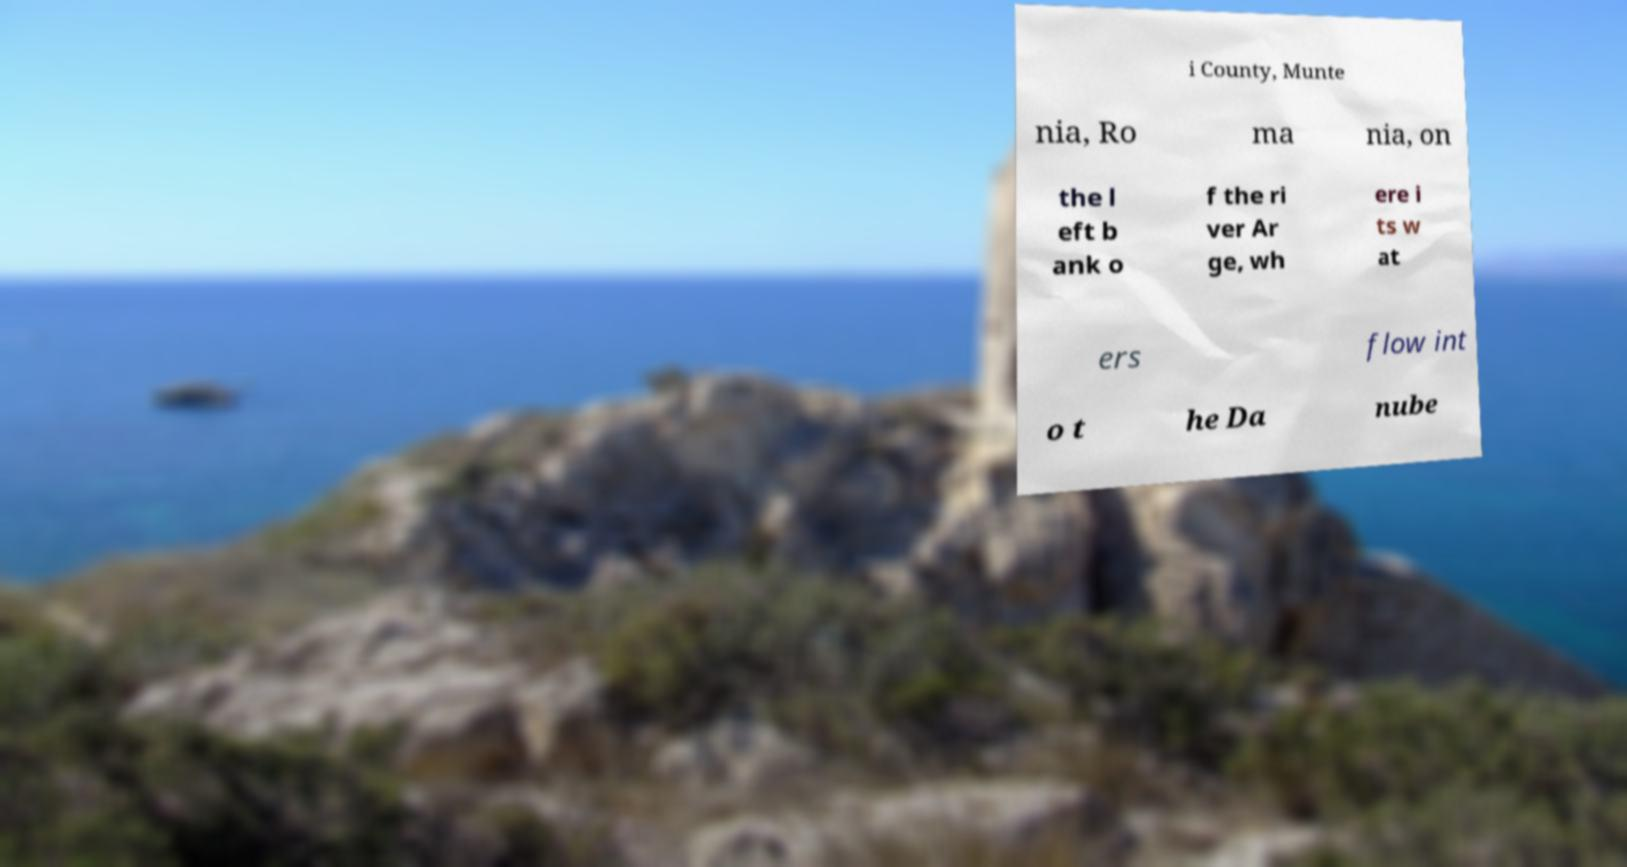Could you assist in decoding the text presented in this image and type it out clearly? i County, Munte nia, Ro ma nia, on the l eft b ank o f the ri ver Ar ge, wh ere i ts w at ers flow int o t he Da nube 